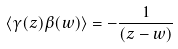<formula> <loc_0><loc_0><loc_500><loc_500>\langle \gamma ( z ) \beta ( w ) \rangle = - \frac { 1 } { ( z - w ) }</formula> 